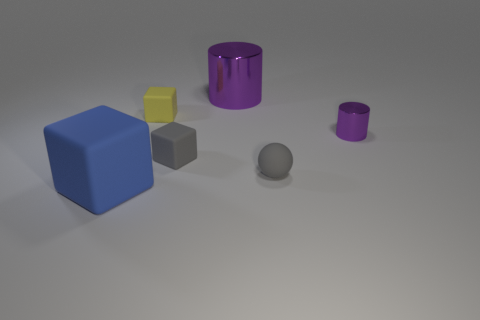Add 3 red matte cubes. How many objects exist? 9 Subtract all gray blocks. How many blocks are left? 2 Subtract 1 gray spheres. How many objects are left? 5 Subtract all cylinders. How many objects are left? 4 Subtract 1 cylinders. How many cylinders are left? 1 Subtract all cyan spheres. Subtract all gray blocks. How many spheres are left? 1 Subtract all brown blocks. How many blue spheres are left? 0 Subtract all metal cylinders. Subtract all purple cylinders. How many objects are left? 2 Add 5 small metal cylinders. How many small metal cylinders are left? 6 Add 5 small gray matte objects. How many small gray matte objects exist? 7 